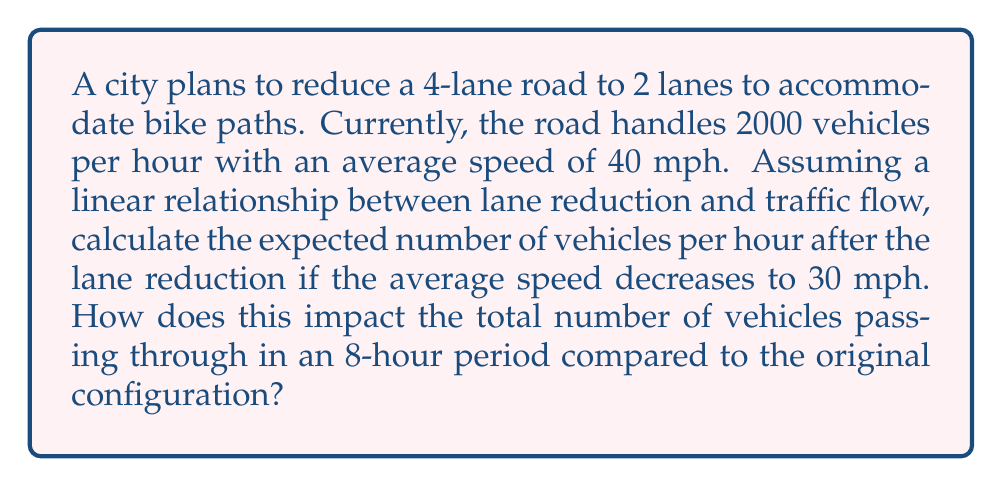Show me your answer to this math problem. Let's approach this step-by-step:

1) First, we need to understand the relationship between lanes, vehicles, and speed:
   - Original configuration: 4 lanes, 2000 vehicles/hour, 40 mph
   - New configuration: 2 lanes, unknown vehicles/hour, 30 mph

2) Assuming a linear relationship between lane reduction and traffic flow:
   - Lanes are reduced by 50% (from 4 to 2)
   - We can expect a 50% reduction in vehicles/hour

3) Calculate the expected vehicles per hour after lane reduction:
   $$2000 \times 0.5 = 1000\text{ vehicles/hour}$$

4) However, we also need to account for the speed reduction:
   - Original speed: 40 mph
   - New speed: 30 mph
   - Speed reduction factor: $\frac{30}{40} = 0.75$

5) Adjust the vehicles/hour based on speed reduction:
   $$1000 \times 0.75 = 750\text{ vehicles/hour}$$

6) Calculate the impact over an 8-hour period:
   - Original configuration: $2000 \times 8 = 16000\text{ vehicles}$
   - New configuration: $750 \times 8 = 6000\text{ vehicles}$

7) Calculate the difference:
   $$16000 - 6000 = 10000\text{ fewer vehicles}$$

8) Calculate the percentage decrease:
   $$\frac{10000}{16000} \times 100 = 62.5\%\text{ decrease}$$
Answer: 750 vehicles/hour; 10000 fewer vehicles (62.5% decrease) over 8 hours 